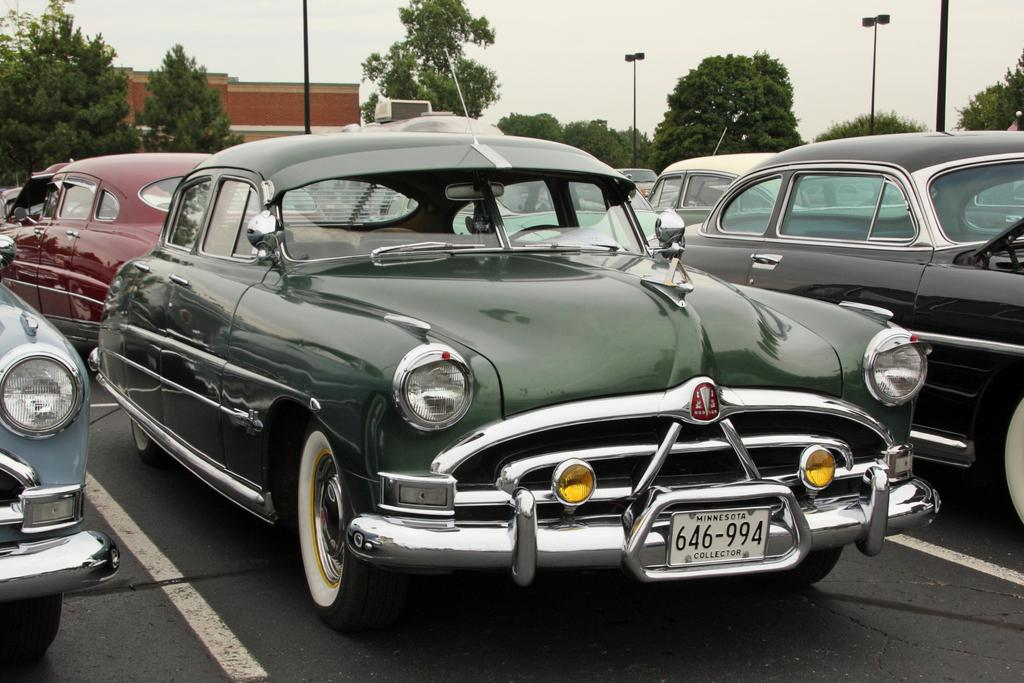What type of vehicles can be seen in the image? There are cars in the image. What structure is visible in the image? There is a building wall in the image. What are the tall, thin objects in the image? There are poles in the image. What type of vegetation is present in the image? There are trees in the image. What is visible at the top of the image? The sky is visible at the top of the image. What type of fruit is hanging from the poles in the image? There is no fruit hanging from the poles in the image; they are just poles. Can you tell me how many people are taking a bath in the image? There is no indication of anyone taking a bath in the image. 